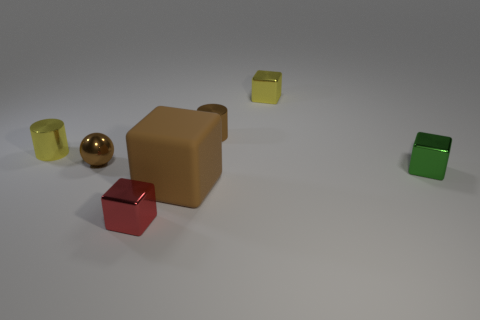Subtract 1 cubes. How many cubes are left? 3 Add 2 small green cubes. How many objects exist? 9 Subtract all spheres. How many objects are left? 6 Add 6 tiny blocks. How many tiny blocks are left? 9 Add 1 purple spheres. How many purple spheres exist? 1 Subtract 0 gray cylinders. How many objects are left? 7 Subtract all small green metal blocks. Subtract all yellow metal cylinders. How many objects are left? 5 